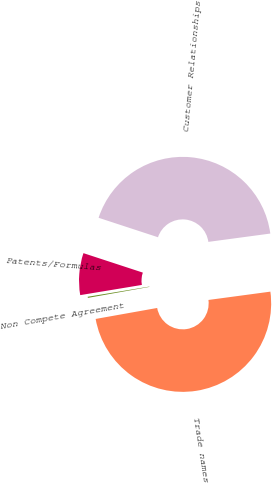<chart> <loc_0><loc_0><loc_500><loc_500><pie_chart><fcel>Trade names<fcel>Customer Relationships<fcel>Patents/Formulas<fcel>Non Compete Agreement<nl><fcel>49.31%<fcel>42.83%<fcel>7.65%<fcel>0.2%<nl></chart> 